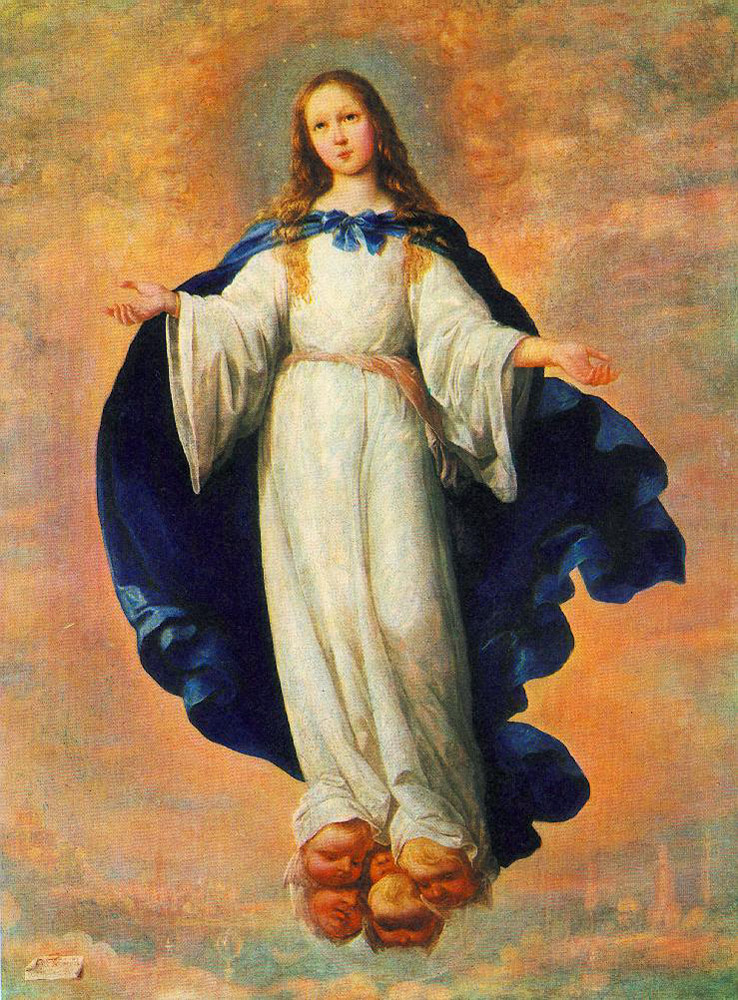What do you think is going on in this snapshot? The image depicts a young girl, possibly an angelic or celestial figure, floating above a cityscape. She wears a simple white dress with a bold blue cloak, and her blond hair flows gracefully. Her open arms and serene expression might suggest themes of peace or protection. This setting, combined with her ethereal appearance and the cloudy, golden-hued sky, strongly hints at religious or spiritual symbolism, perhaps representing a guardian watching over the city. 